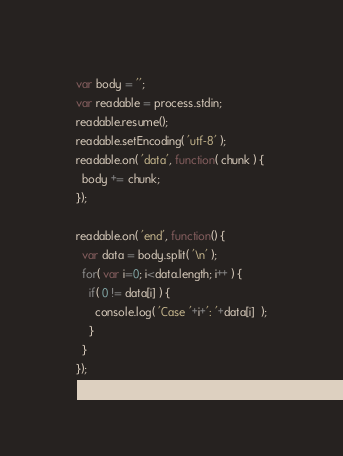Convert code to text. <code><loc_0><loc_0><loc_500><loc_500><_JavaScript_>var body = '';
var readable = process.stdin;
readable.resume();
readable.setEncoding( 'utf-8' );
readable.on( 'data', function( chunk ) {
  body += chunk;
});

readable.on( 'end', function() {
  var data = body.split( '\n' );
  for( var i=0; i<data.length; i++ ) {
    if( 0 != data[i] ) {  
      console.log( 'Case '+i+': '+data[i]  );
    }
  }
});</code> 